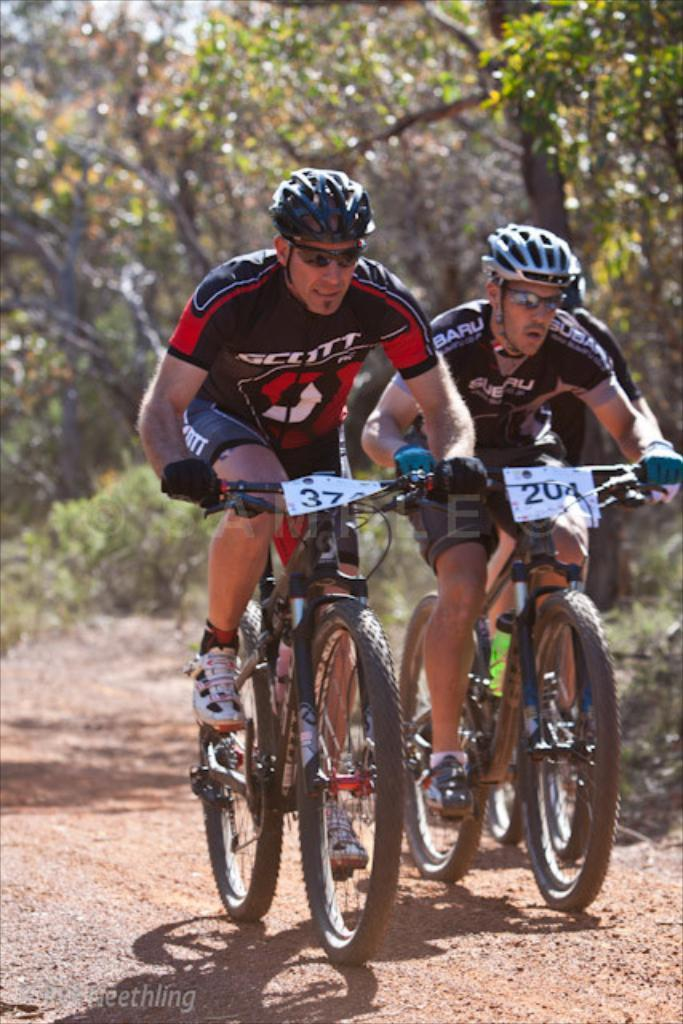How many people are in the image? There are three people in the image. What are the people doing in the image? The people are riding bikes. Are there any identifiers on the bikes? Yes, there are number stickers attached to the bikes. What can be seen in the background of the image? There are trees visible in the background of the image. Where is the library located in the image? There is no library present in the image. How many tomatoes are being carried by the people riding bikes? There are no tomatoes visible in the image; the people are riding bikes with number stickers attached. 